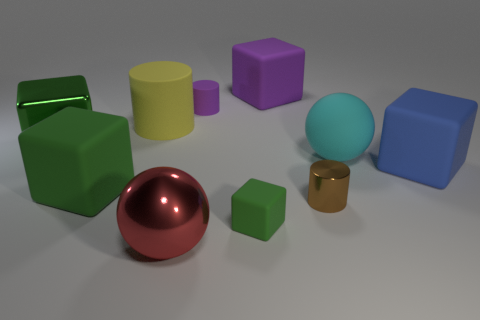Subtract all red cylinders. How many green cubes are left? 3 Subtract all blue blocks. How many blocks are left? 4 Subtract all large blue matte blocks. How many blocks are left? 4 Subtract all yellow blocks. Subtract all yellow spheres. How many blocks are left? 5 Subtract all cylinders. How many objects are left? 7 Add 1 large green matte balls. How many large green matte balls exist? 1 Subtract 0 blue cylinders. How many objects are left? 10 Subtract all big red metallic things. Subtract all small cubes. How many objects are left? 8 Add 5 yellow objects. How many yellow objects are left? 6 